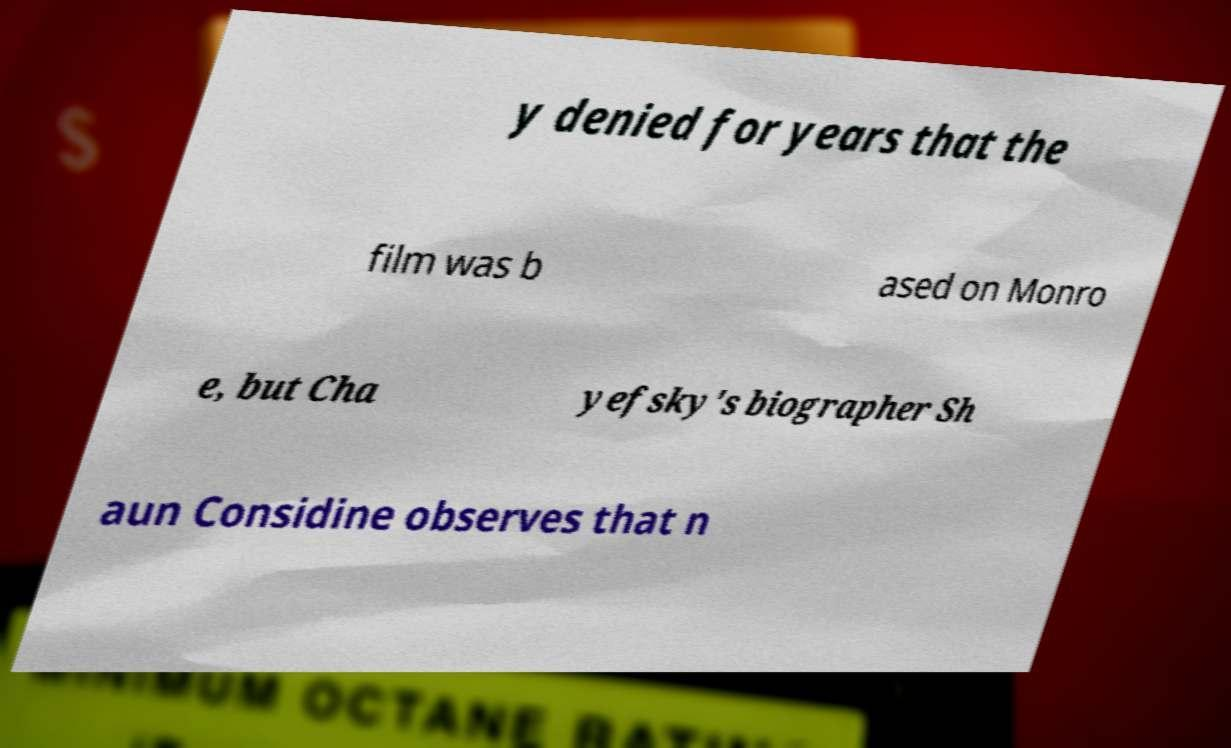Can you read and provide the text displayed in the image?This photo seems to have some interesting text. Can you extract and type it out for me? y denied for years that the film was b ased on Monro e, but Cha yefsky's biographer Sh aun Considine observes that n 